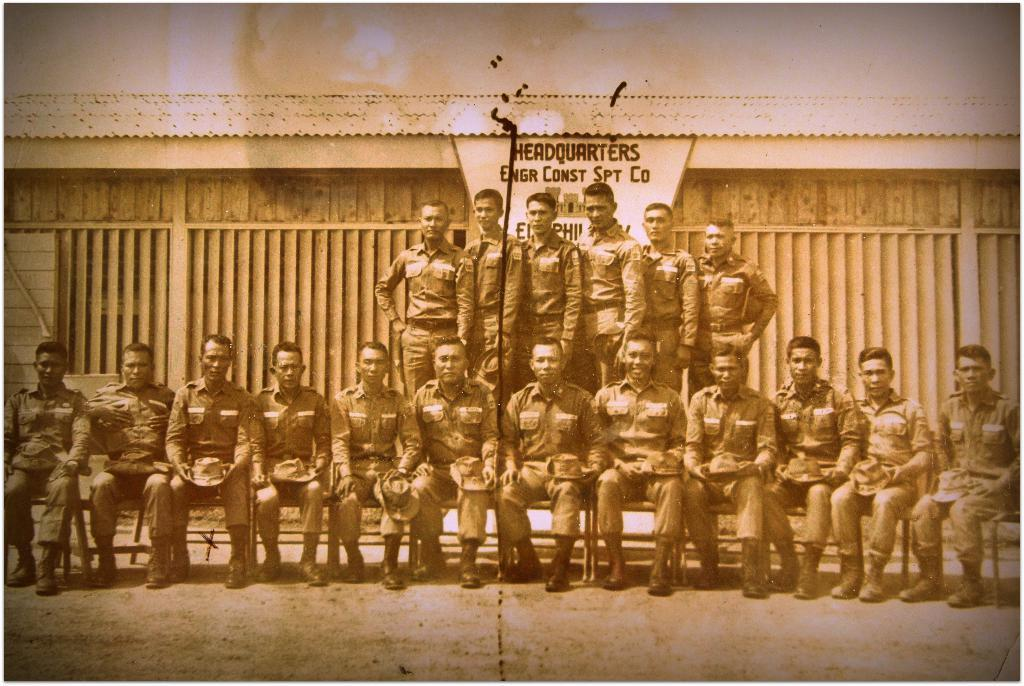What are the people in the image doing? There are people sitting and standing in the image. What can be seen in the background of the image? There is a board visible in the image. What is written on the board? There is something written on the board. How many tails can be seen on the people in the image? There are no tails visible on the people in the image. What type of edge is present on the board in the image? The provided facts do not mention the type of edge on the board, so it cannot be determined from the image. 